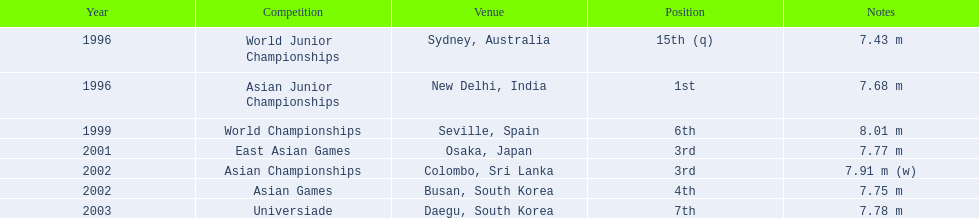What are the competitor's rankings across different competitions? 15th (q), 1st, 6th, 3rd, 3rd, 4th, 7th. In which event did they achieve 1st place? Asian Junior Championships. 